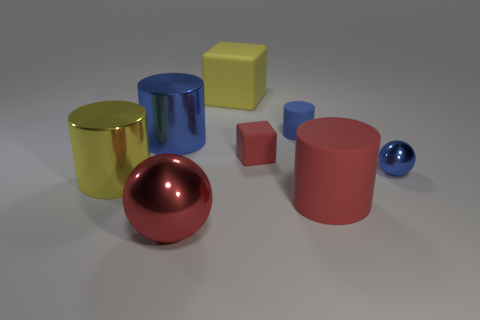There is a blue rubber object that is the same shape as the big red matte thing; what is its size?
Your answer should be very brief. Small. Are there any large cylinders?
Provide a short and direct response. Yes. How many things are big yellow things that are behind the tiny red rubber block or red cylinders?
Keep it short and to the point. 2. There is a cube that is the same size as the blue rubber object; what is it made of?
Provide a succinct answer. Rubber. The shiny thing that is in front of the yellow object that is to the left of the large yellow block is what color?
Ensure brevity in your answer.  Red. There is a red rubber cylinder; what number of big cylinders are to the left of it?
Your answer should be compact. 2. The big metal ball has what color?
Ensure brevity in your answer.  Red. What number of large things are metallic cylinders or red objects?
Keep it short and to the point. 4. Is the color of the shiny thing right of the big red rubber thing the same as the shiny thing behind the blue metallic sphere?
Offer a terse response. Yes. How many other things are there of the same color as the small cylinder?
Offer a terse response. 2. 